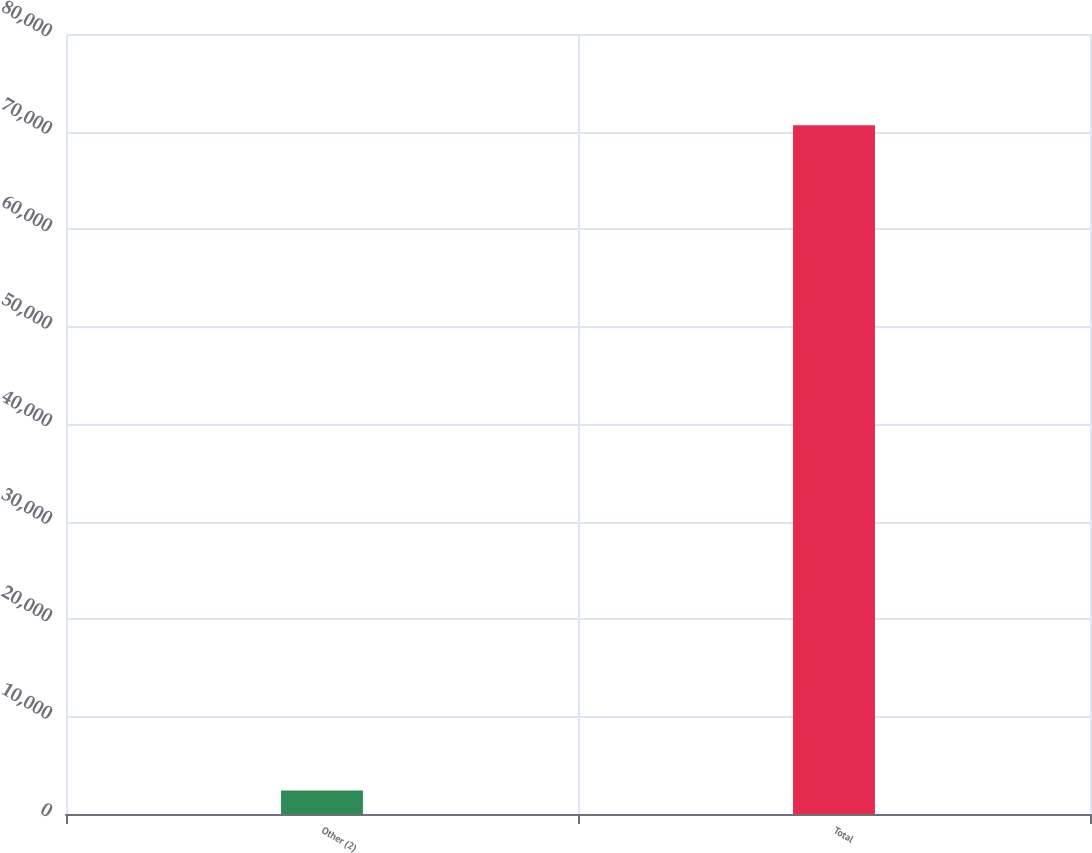<chart> <loc_0><loc_0><loc_500><loc_500><bar_chart><fcel>Other (2)<fcel>Total<nl><fcel>2399<fcel>70644<nl></chart> 